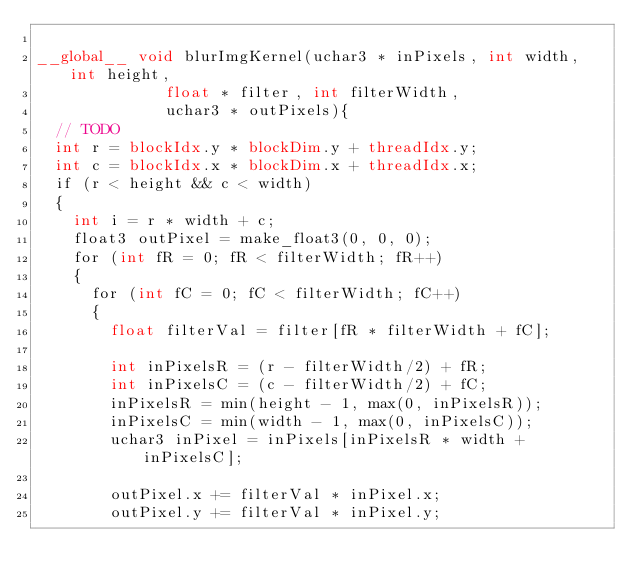<code> <loc_0><loc_0><loc_500><loc_500><_Cuda_>
__global__ void blurImgKernel(uchar3 * inPixels, int width, int height, 
							float * filter, int filterWidth, 
							uchar3 * outPixels){
	// TODO
	int r = blockIdx.y * blockDim.y + threadIdx.y;
	int c = blockIdx.x * blockDim.x + threadIdx.x;
	if (r < height && c < width)
	{
		int i = r * width + c;
		float3 outPixel = make_float3(0, 0, 0);
		for (int fR = 0; fR < filterWidth; fR++)
		{
			for (int fC = 0; fC < filterWidth; fC++)
			{
				float filterVal = filter[fR * filterWidth + fC];

				int inPixelsR = (r - filterWidth/2) + fR;
				int inPixelsC = (c - filterWidth/2) + fC;
				inPixelsR = min(height - 1, max(0, inPixelsR)); 
				inPixelsC = min(width - 1, max(0, inPixelsC)); 
				uchar3 inPixel = inPixels[inPixelsR * width + inPixelsC];
				
				outPixel.x += filterVal * inPixel.x;
				outPixel.y += filterVal * inPixel.y;</code> 